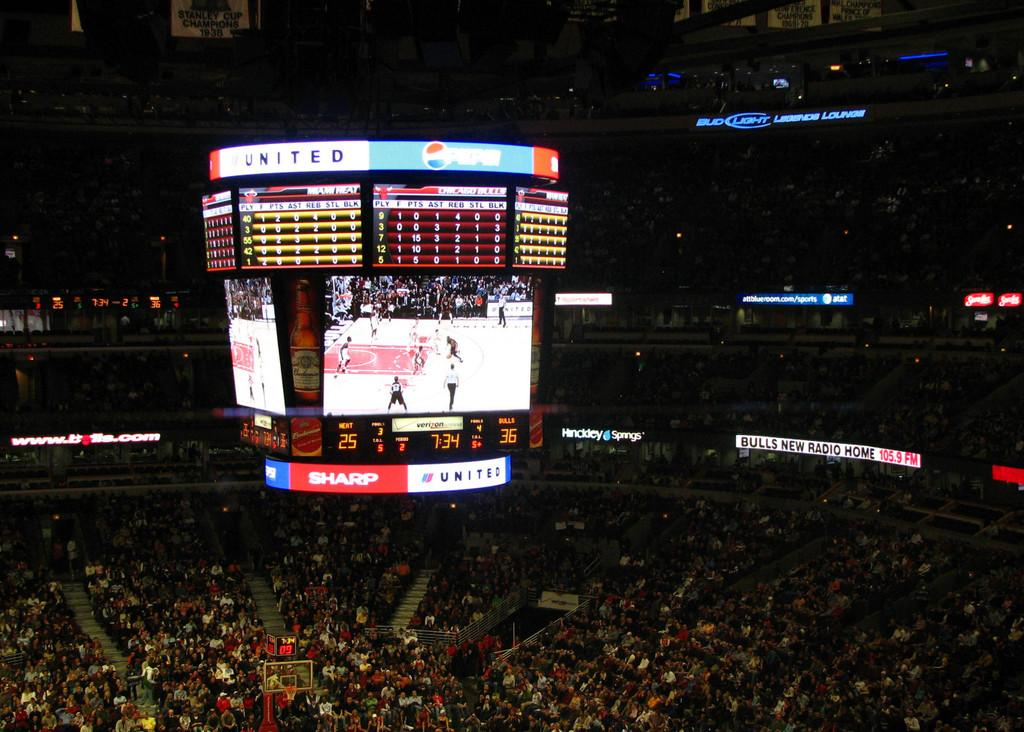<image>
Give a short and clear explanation of the subsequent image. A video screen of a game in a crowded stadium displays ads for Sharp, United and other companies. 